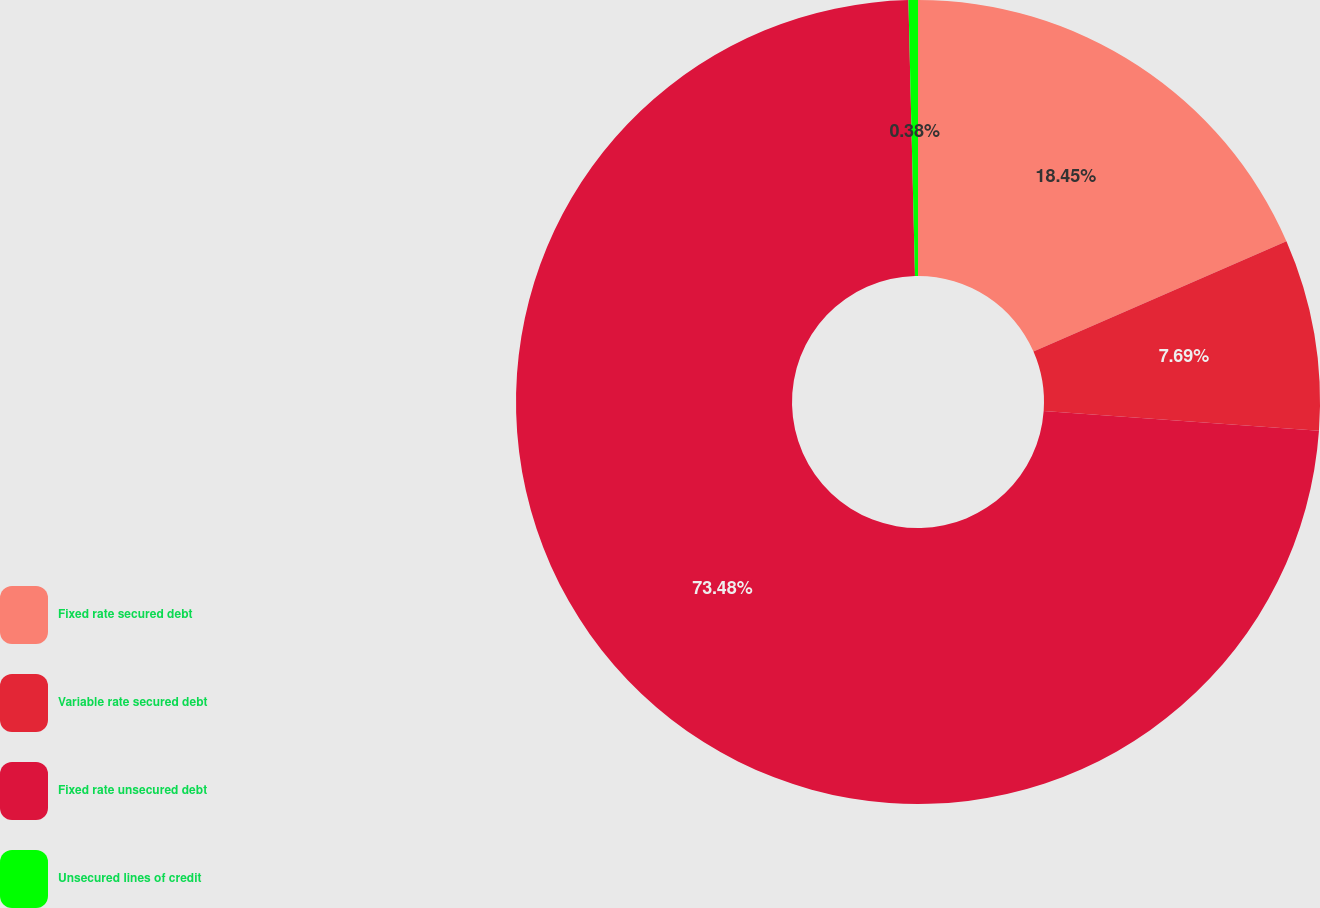Convert chart. <chart><loc_0><loc_0><loc_500><loc_500><pie_chart><fcel>Fixed rate secured debt<fcel>Variable rate secured debt<fcel>Fixed rate unsecured debt<fcel>Unsecured lines of credit<nl><fcel>18.45%<fcel>7.69%<fcel>73.48%<fcel>0.38%<nl></chart> 